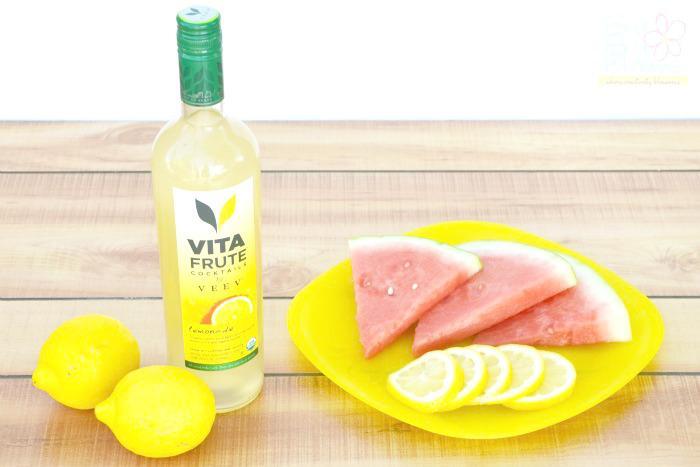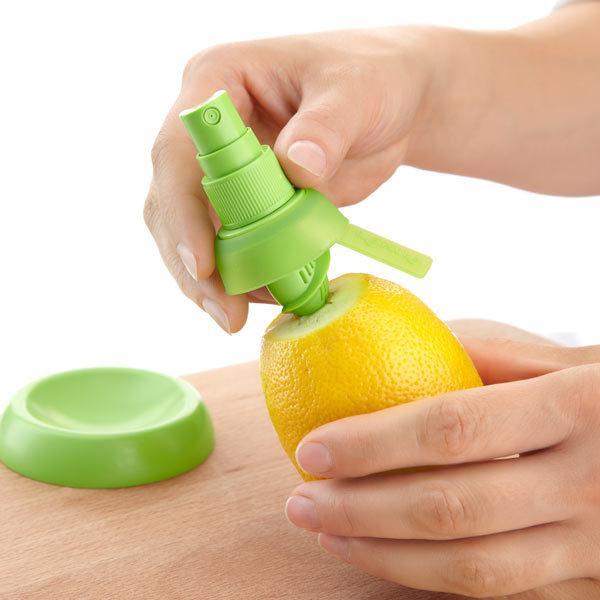The first image is the image on the left, the second image is the image on the right. Considering the images on both sides, is "A person is holding the lemon in the image on the right." valid? Answer yes or no. Yes. 